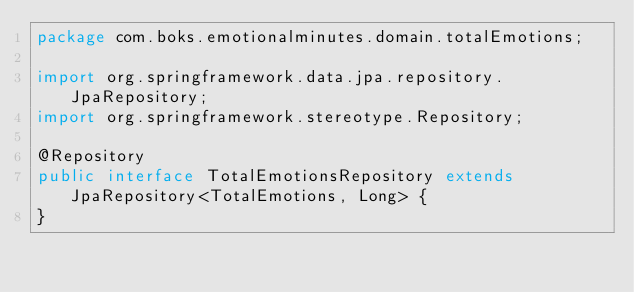Convert code to text. <code><loc_0><loc_0><loc_500><loc_500><_Java_>package com.boks.emotionalminutes.domain.totalEmotions;

import org.springframework.data.jpa.repository.JpaRepository;
import org.springframework.stereotype.Repository;

@Repository
public interface TotalEmotionsRepository extends JpaRepository<TotalEmotions, Long> {
}
</code> 